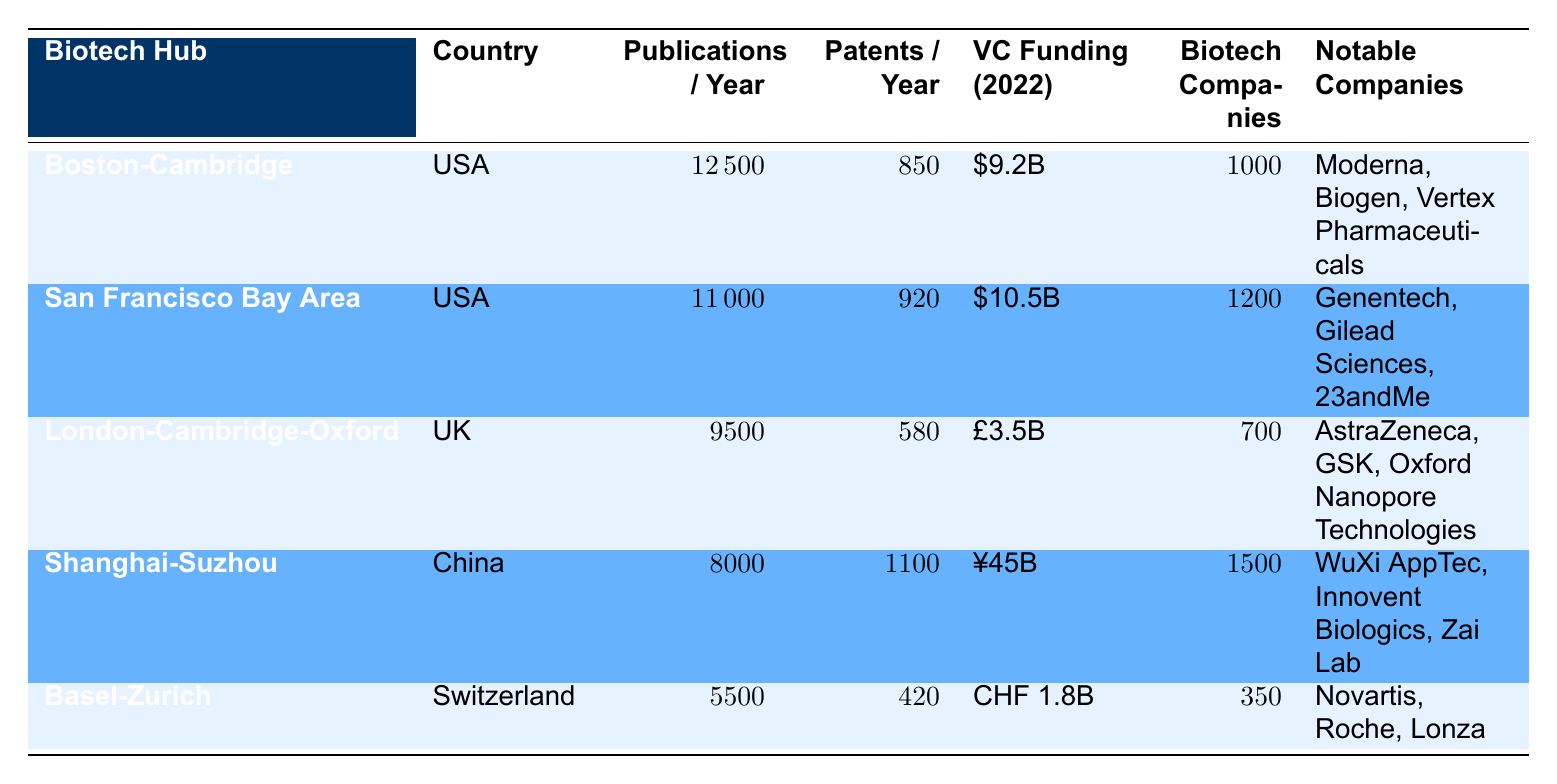What is the highest number of publications per year among the biotech hubs? Looking at the table, Boston-Cambridge has 12,500 publications per year, which is higher than San Francisco Bay Area (11,000), London-Cambridge-Oxford (9,500), Shanghai-Suzhou (8,000), and Basel-Zurich (5,500). Thus, it has the highest number.
Answer: 12,500 Which biotech hub has the most patents filed annually? From the table, Shanghai-Suzhou has 1,100 patents filed annually, which is more than the other hubs: San Francisco Bay Area (920), Boston-Cambridge (850), London-Cambridge-Oxford (580), and Basel-Zurich (420).
Answer: Shanghai-Suzhou How much total venture capital was reported for all hubs in 2022 when converted to a common currency? The venture capital for Boston-Cambridge is 9.2 billion USD, San Francisco Bay Area is 10.5 billion USD, London-Cambridge-Oxford is roughly 4.5 billion USD (3.5 billion GBP converted), Shanghai-Suzhou is approximately 6.4 billion USD (45 billion CNY converted), and Basel-Zurich is roughly 2 billion USD (1.8 billion CHF converted). Adding these together gives 32.6 billion USD.
Answer: 32.6 billion USD Is it true that London-Cambridge-Oxford has more biotech companies than Basel-Zurich? Yes, the table shows London-Cambridge-Oxford has 700 biotech companies while Basel-Zurich only has 350. This confirms that London-Cambridge-Oxford has more.
Answer: Yes Which hub has the highest average seed round amount and how does it compare to Boston-Cambridge? The San Francisco Bay Area has the highest average seed round of 4 million USD, compared to Boston-Cambridge, which has 3.5 million USD. Thus, it is 0.5 million USD higher than Boston-Cambridge.
Answer: 4 million USD, 0.5 million USD higher than Boston-Cambridge What is the difference in the number of biotech companies between Shanghai-Suzhou and San Francisco Bay Area? Shanghai-Suzhou has 1,500 biotech companies and San Francisco Bay Area has 1,200. The difference is 1,500 - 1,200 = 300.
Answer: 300 Which two biotech hubs have a similar number of research institutions, and what is that number? London-Cambridge-Oxford has 45 research institutions and Shanghai-Suzhou has 35. They are not similar enough but overall, London-Cambridge-Oxford has more. If we consider similar, it would potentially be London-Cambridge-Oxford and Basel-Zurich, which have 45 and 25 respectively.
Answer: None Is San Francisco Bay Area the only hub with more than 10 billion USD in venture capital funding? Yes, the only hub with more than 10 billion in venture capital is indeed San Francisco Bay Area with 10.5 billion USD.
Answer: Yes How many pharma giants are present in Boston-Cambridge compared to London-Cambridge-Oxford? Boston-Cambridge has 5 pharma giants while London-Cambridge-Oxford has 4 pharma giants. Thus, Boston-Cambridge has 1 more than London-Cambridge-Oxford.
Answer: 1 more in Boston-Cambridge 